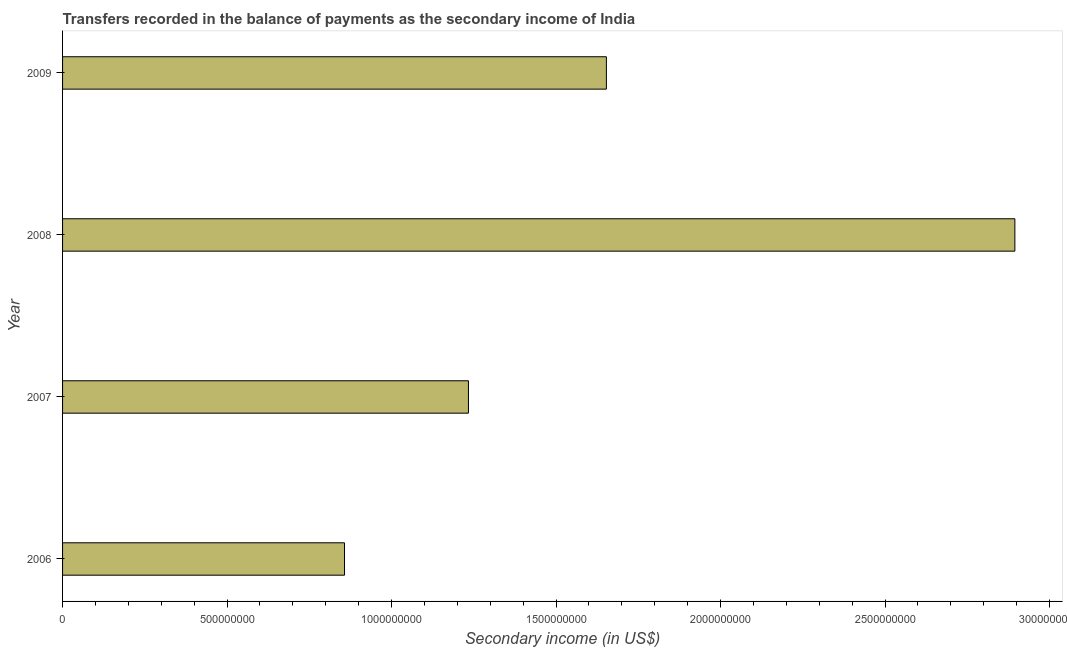What is the title of the graph?
Offer a very short reply. Transfers recorded in the balance of payments as the secondary income of India. What is the label or title of the X-axis?
Your response must be concise. Secondary income (in US$). What is the label or title of the Y-axis?
Provide a succinct answer. Year. What is the amount of secondary income in 2008?
Make the answer very short. 2.89e+09. Across all years, what is the maximum amount of secondary income?
Offer a very short reply. 2.89e+09. Across all years, what is the minimum amount of secondary income?
Offer a terse response. 8.57e+08. In which year was the amount of secondary income maximum?
Offer a terse response. 2008. What is the sum of the amount of secondary income?
Make the answer very short. 6.64e+09. What is the difference between the amount of secondary income in 2007 and 2008?
Offer a terse response. -1.66e+09. What is the average amount of secondary income per year?
Your answer should be very brief. 1.66e+09. What is the median amount of secondary income?
Your response must be concise. 1.44e+09. What is the ratio of the amount of secondary income in 2006 to that in 2007?
Provide a succinct answer. 0.69. Is the amount of secondary income in 2007 less than that in 2008?
Provide a short and direct response. Yes. Is the difference between the amount of secondary income in 2006 and 2009 greater than the difference between any two years?
Keep it short and to the point. No. What is the difference between the highest and the second highest amount of secondary income?
Ensure brevity in your answer.  1.24e+09. Is the sum of the amount of secondary income in 2007 and 2008 greater than the maximum amount of secondary income across all years?
Provide a succinct answer. Yes. What is the difference between the highest and the lowest amount of secondary income?
Your answer should be compact. 2.04e+09. In how many years, is the amount of secondary income greater than the average amount of secondary income taken over all years?
Your answer should be compact. 1. How many years are there in the graph?
Provide a succinct answer. 4. What is the difference between two consecutive major ticks on the X-axis?
Offer a very short reply. 5.00e+08. Are the values on the major ticks of X-axis written in scientific E-notation?
Offer a very short reply. No. What is the Secondary income (in US$) in 2006?
Provide a succinct answer. 8.57e+08. What is the Secondary income (in US$) in 2007?
Offer a terse response. 1.23e+09. What is the Secondary income (in US$) of 2008?
Make the answer very short. 2.89e+09. What is the Secondary income (in US$) in 2009?
Offer a very short reply. 1.65e+09. What is the difference between the Secondary income (in US$) in 2006 and 2007?
Your response must be concise. -3.77e+08. What is the difference between the Secondary income (in US$) in 2006 and 2008?
Your answer should be very brief. -2.04e+09. What is the difference between the Secondary income (in US$) in 2006 and 2009?
Keep it short and to the point. -7.96e+08. What is the difference between the Secondary income (in US$) in 2007 and 2008?
Keep it short and to the point. -1.66e+09. What is the difference between the Secondary income (in US$) in 2007 and 2009?
Your answer should be very brief. -4.19e+08. What is the difference between the Secondary income (in US$) in 2008 and 2009?
Provide a succinct answer. 1.24e+09. What is the ratio of the Secondary income (in US$) in 2006 to that in 2007?
Give a very brief answer. 0.69. What is the ratio of the Secondary income (in US$) in 2006 to that in 2008?
Your response must be concise. 0.3. What is the ratio of the Secondary income (in US$) in 2006 to that in 2009?
Your response must be concise. 0.52. What is the ratio of the Secondary income (in US$) in 2007 to that in 2008?
Your answer should be compact. 0.43. What is the ratio of the Secondary income (in US$) in 2007 to that in 2009?
Provide a short and direct response. 0.75. What is the ratio of the Secondary income (in US$) in 2008 to that in 2009?
Provide a short and direct response. 1.75. 